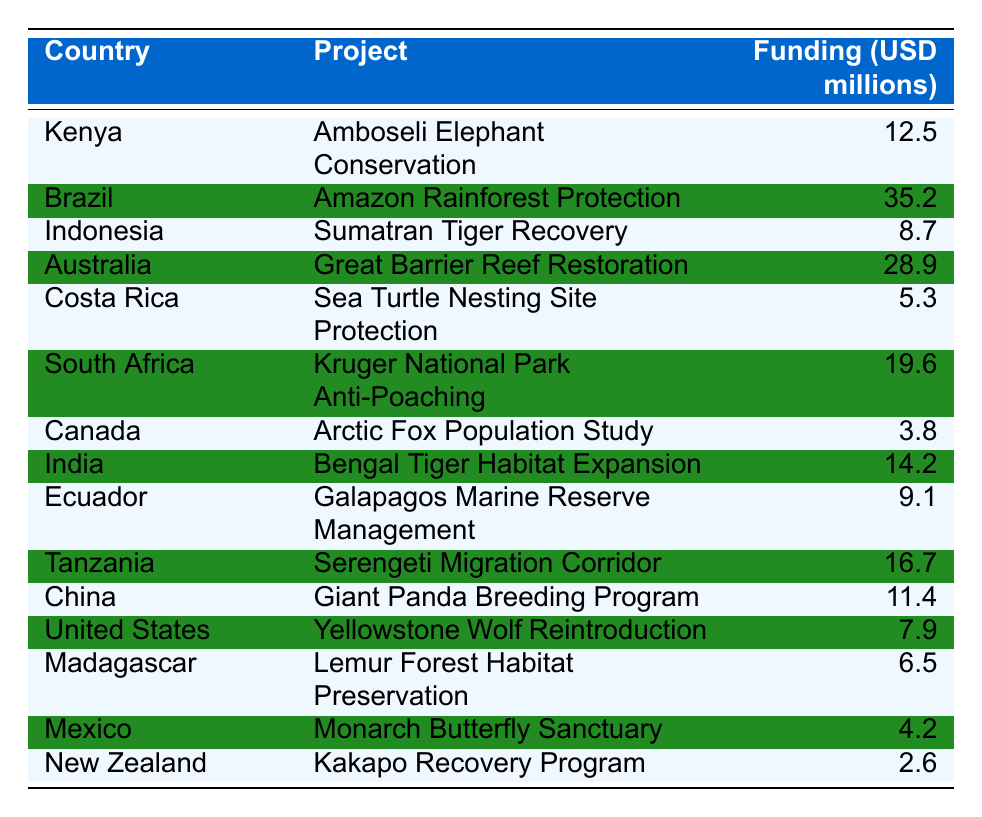What is the total funding amount allocated to projects in Australia and Brazil? The funding for Australia is 28.9 million USD and for Brazil is 35.2 million USD. To find the total, we add these together: 28.9 + 35.2 = 64.1 million USD.
Answer: 64.1 million USD Which country received the least funding for wildlife conservation projects? The country with the least funding is New Zealand, which received 2.6 million USD.
Answer: New Zealand How many projects received over 15 million USD in funding? The projects with over 15 million USD in funding are: Amazon Rainforest Protection (35.2), Great Barrier Reef Restoration (28.9), Kruger National Park Anti-Poaching (19.6), and Serengeti Migration Corridor (16.7). That's a total of 4 projects.
Answer: 4 Is there any country that is involved in both projects that received funding over 10 million USD? Yes, South Africa's project, Kruger National Park Anti-Poaching, received 19.6 million USD, while India's Bengal Tiger Habitat Expansion received 14.2 million USD. Both countries are involved in projects with funding over 10 million USD.
Answer: Yes What is the average funding amount for the projects funded in Central America? The projects funded in Central America are: Sea Turtle Nesting Site Protection in Costa Rica (5.3) and Monarch Butterfly Sanctuary in Mexico (4.2). The total funding for these two projects is 5.3 + 4.2 = 9.5 million USD. The average is 9.5 / 2 = 4.75 million USD.
Answer: 4.75 million USD Which project received more funding: the Giant Panda Breeding Program or the Sea Turtle Nesting Site Protection? The Giant Panda Breeding Program in China received 11.4 million USD, while the Sea Turtle Nesting Site Protection in Costa Rica received 5.3 million USD. 11.4 million USD is greater than 5.3 million USD.
Answer: Giant Panda Breeding Program What percentage of the total funding (sum of all projects) goes to the Amazon Rainforest Protection project? First, we calculate the total funding by summing all the projects: 12.5 + 35.2 + 8.7 + 28.9 + 5.3 + 19.6 + 3.8 + 14.2 + 9.1 + 16.7 + 11.4 + 7.9 + 6.5 + 4.2 + 2.6 =  378.1 million USD. The Amazon Rainforest Protection project received 35.2 million USD, so the percentage is (35.2 / 378.1) * 100 ≈ 9.30%.
Answer: Approximately 9.30% How much more funding did Brasil's Amazon Rainforest Protection project receive than the total funding of Canada's Arctic Fox Population Study and New Zealand's Kakapo Recovery Program combined? Brazil's Amazon Rainforest Protection project received 35.2 million USD. The total funding for Canada's project is 3.8 million USD and New Zealand's project is 2.6 million USD, adding these gives us 3.8 + 2.6 = 6.4 million USD. The difference is 35.2 - 6.4 = 28.8 million USD.
Answer: 28.8 million USD What is the sum of the funding amounts for projects located in African countries? The projects in African countries and their funding amounts are: Amboseli Elephant Conservation in Kenya (12.5), Kruger National Park Anti-Poaching in South Africa (19.6), and Serengeti Migration Corridor in Tanzania (16.7). The total funding is 12.5 + 19.6 + 16.7 = 48.8 million USD.
Answer: 48.8 million USD Does the funding allocated to the Giant Panda Breeding Program exceed the sum of the funding allocated to both the Kakapo Recovery Program and the Arctic Fox Population Study? The Giant Panda Breeding Program received 11.4 million USD. Adding the other two projects gives us Kakapo Recovery Program (2.6) + Arctic Fox Population Study (3.8) = 6.4 million USD. Since 11.4 is greater than 6.4, the answer is yes.
Answer: Yes 